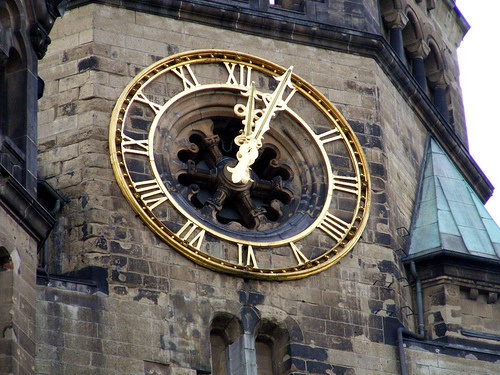Describe the objects in this image and their specific colors. I can see a clock in black, gray, beige, and maroon tones in this image. 